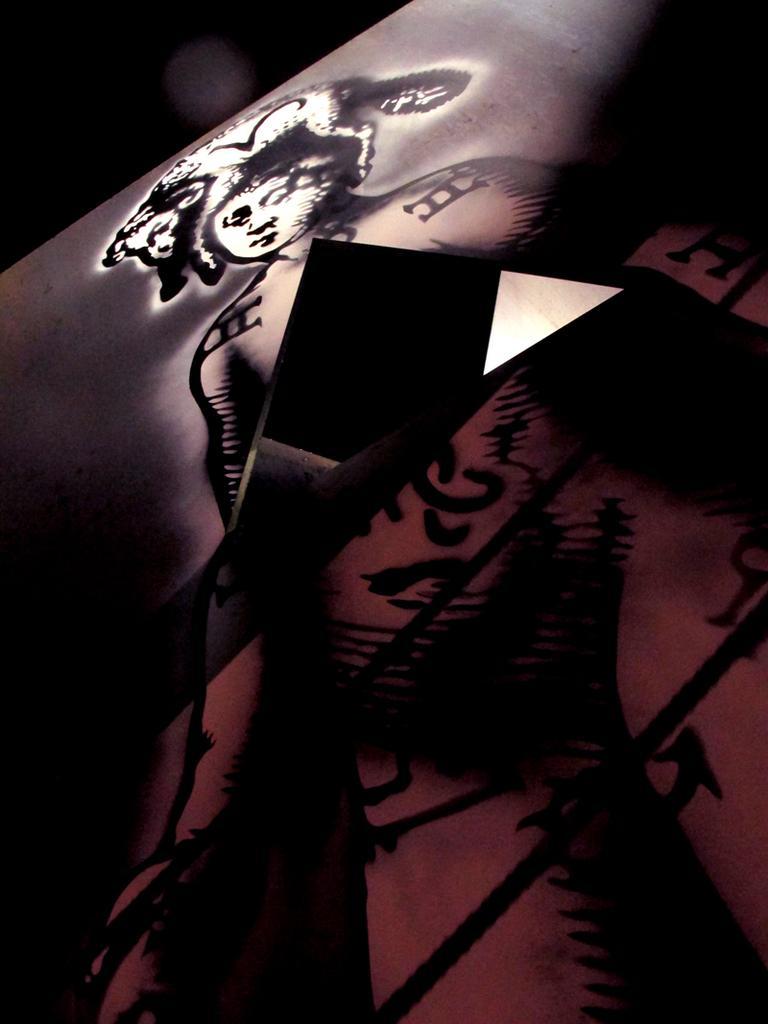In one or two sentences, can you explain what this image depicts? We can see designs and a picture on a board and there is a triangular cut in the middle of the board. 